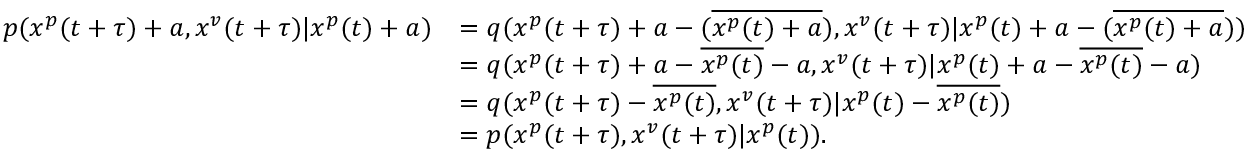<formula> <loc_0><loc_0><loc_500><loc_500>\begin{array} { r l } { p ( x ^ { p } ( t + \tau ) + a , x ^ { v } ( t + \tau ) | x ^ { p } ( t ) + a ) } & { = q ( x ^ { p } ( t + \tau ) + a - ( \overline { { x ^ { p } ( t ) + a } } ) , x ^ { v } ( t + \tau ) | x ^ { p } ( t ) + a - ( \overline { { x ^ { p } ( t ) + a } } ) ) } \\ & { = q ( x ^ { p } ( t + \tau ) + a - \overline { { x ^ { p } ( t ) } } - a , x ^ { v } ( t + \tau ) | x ^ { p } ( t ) + a - \overline { { x ^ { p } ( t ) } } - a ) } \\ & { = q ( x ^ { p } ( t + \tau ) - \overline { { x ^ { p } ( t ) } } , x ^ { v } ( t + \tau ) | x ^ { p } ( t ) - \overline { { x ^ { p } ( t ) } } ) } \\ & { = p ( x ^ { p } ( t + \tau ) , x ^ { v } ( t + \tau ) | x ^ { p } ( t ) ) . } \end{array}</formula> 